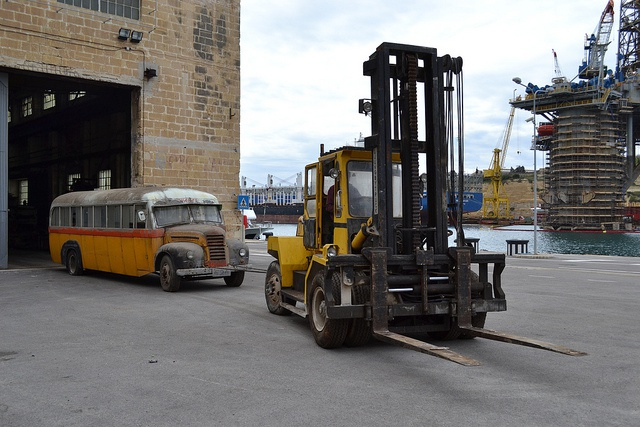Describe the objects in this image and their specific colors. I can see bus in gray, black, and maroon tones, boat in gray, black, and darkgray tones, boat in gray, white, darkgray, and black tones, and people in gray, black, and olive tones in this image. 